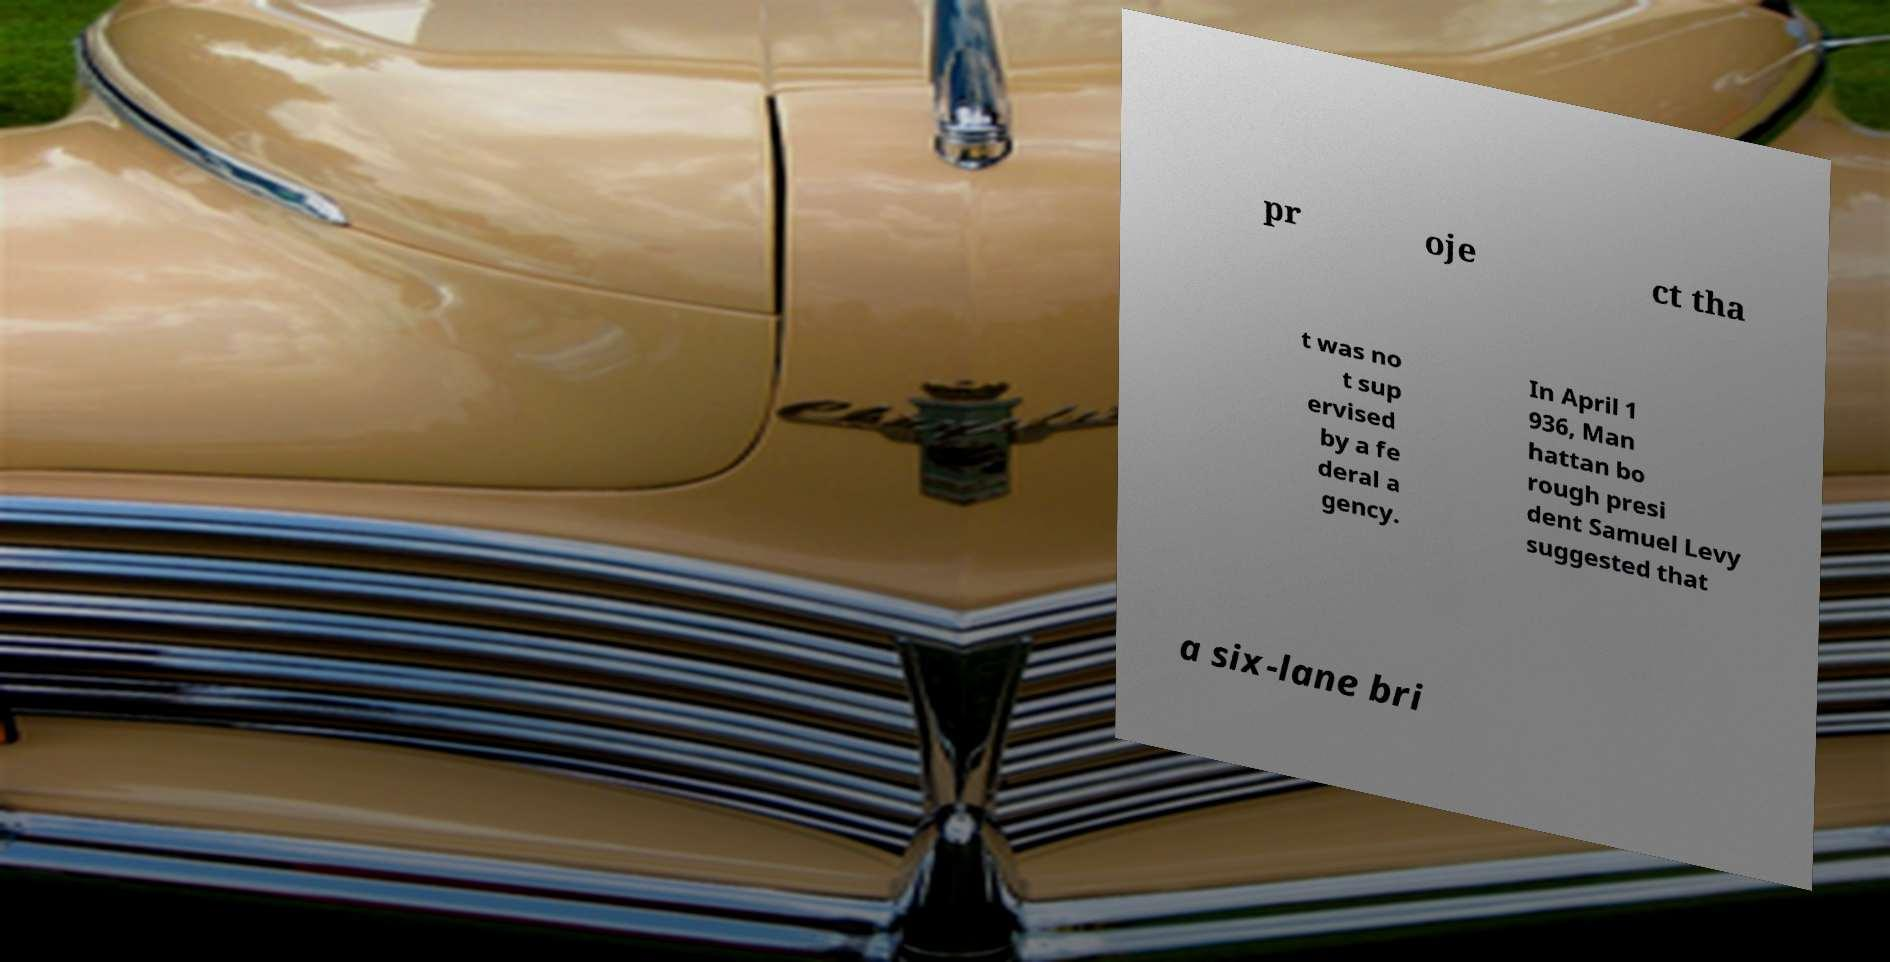Can you read and provide the text displayed in the image?This photo seems to have some interesting text. Can you extract and type it out for me? pr oje ct tha t was no t sup ervised by a fe deral a gency. In April 1 936, Man hattan bo rough presi dent Samuel Levy suggested that a six-lane bri 